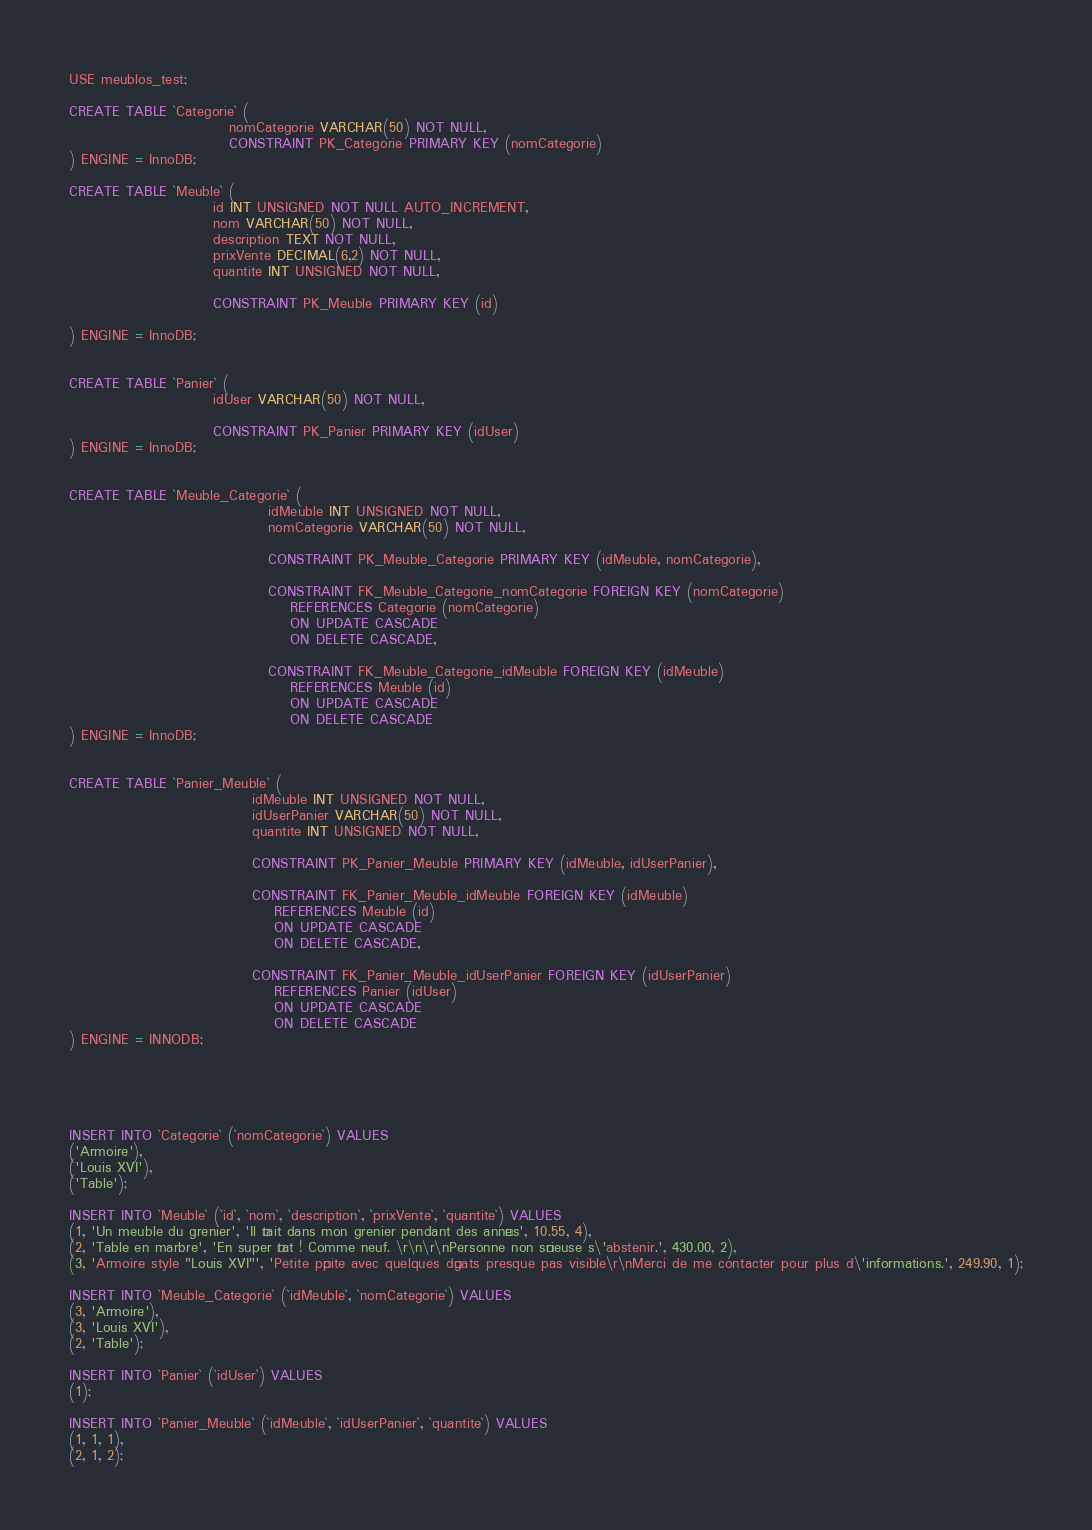Convert code to text. <code><loc_0><loc_0><loc_500><loc_500><_SQL_>
USE meublos_test;

CREATE TABLE `Categorie` (
                             nomCategorie VARCHAR(50) NOT NULL,
                             CONSTRAINT PK_Categorie PRIMARY KEY (nomCategorie)
) ENGINE = InnoDB;

CREATE TABLE `Meuble` (
                          id INT UNSIGNED NOT NULL AUTO_INCREMENT,
                          nom VARCHAR(50) NOT NULL,
                          description TEXT NOT NULL,
                          prixVente DECIMAL(6,2) NOT NULL,
                          quantite INT UNSIGNED NOT NULL,

                          CONSTRAINT PK_Meuble PRIMARY KEY (id)

) ENGINE = InnoDB;


CREATE TABLE `Panier` (
                          idUser VARCHAR(50) NOT NULL,

                          CONSTRAINT PK_Panier PRIMARY KEY (idUser)
) ENGINE = InnoDB;


CREATE TABLE `Meuble_Categorie` (
                                    idMeuble INT UNSIGNED NOT NULL,
                                    nomCategorie VARCHAR(50) NOT NULL,

                                    CONSTRAINT PK_Meuble_Categorie PRIMARY KEY (idMeuble, nomCategorie),

                                    CONSTRAINT FK_Meuble_Categorie_nomCategorie FOREIGN KEY (nomCategorie)
                                        REFERENCES Categorie (nomCategorie)
                                        ON UPDATE CASCADE
                                        ON DELETE CASCADE,

                                    CONSTRAINT FK_Meuble_Categorie_idMeuble FOREIGN KEY (idMeuble)
                                        REFERENCES Meuble (id)
                                        ON UPDATE CASCADE
                                        ON DELETE CASCADE
) ENGINE = InnoDB;


CREATE TABLE `Panier_Meuble` (
                                 idMeuble INT UNSIGNED NOT NULL,
                                 idUserPanier VARCHAR(50) NOT NULL,
                                 quantite INT UNSIGNED NOT NULL,

                                 CONSTRAINT PK_Panier_Meuble PRIMARY KEY (idMeuble, idUserPanier),

                                 CONSTRAINT FK_Panier_Meuble_idMeuble FOREIGN KEY (idMeuble)
                                     REFERENCES Meuble (id)
                                     ON UPDATE CASCADE
                                     ON DELETE CASCADE,

                                 CONSTRAINT FK_Panier_Meuble_idUserPanier FOREIGN KEY (idUserPanier)
                                     REFERENCES Panier (idUser)
                                     ON UPDATE CASCADE
                                     ON DELETE CASCADE
) ENGINE = INNODB;





INSERT INTO `Categorie` (`nomCategorie`) VALUES
('Armoire'),
('Louis XVI'),
('Table');

INSERT INTO `Meuble` (`id`, `nom`, `description`, `prixVente`, `quantite`) VALUES
(1, 'Un meuble du grenier', 'Il était dans mon grenier pendant des années', 10.55, 4),
(2, 'Table en marbre', 'En super état ! Comme neuf. \r\n\r\nPersonne non sérieuse s\'abstenir.', 430.00, 2),
(3, 'Armoire style "Louis XVI"', 'Petite pépite avec quelques dégats presque pas visible\r\nMerci de me contacter pour plus d\'informations.', 249.90, 1);

INSERT INTO `Meuble_Categorie` (`idMeuble`, `nomCategorie`) VALUES
(3, 'Armoire'),
(3, 'Louis XVI'),
(2, 'Table');

INSERT INTO `Panier` (`idUser`) VALUES
(1);

INSERT INTO `Panier_Meuble` (`idMeuble`, `idUserPanier`, `quantite`) VALUES
(1, 1, 1),
(2, 1, 2);</code> 